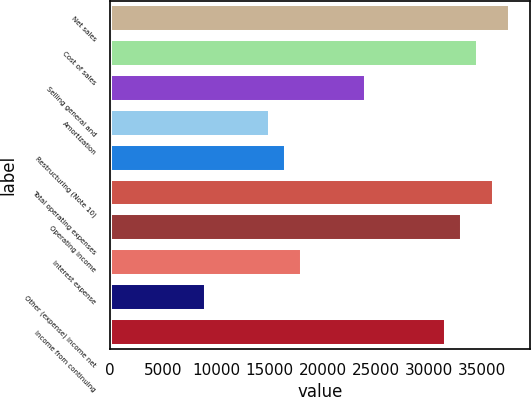<chart> <loc_0><loc_0><loc_500><loc_500><bar_chart><fcel>Net sales<fcel>Cost of sales<fcel>Selling general and<fcel>Amortization<fcel>Restructuring (Note 10)<fcel>Total operating expenses<fcel>Operating income<fcel>Interest expense<fcel>Other (expense) income net<fcel>Income from continuing<nl><fcel>37627.4<fcel>34617.2<fcel>24081.6<fcel>15051<fcel>16556.1<fcel>36122.3<fcel>33112.1<fcel>18061.2<fcel>9030.68<fcel>31607<nl></chart> 